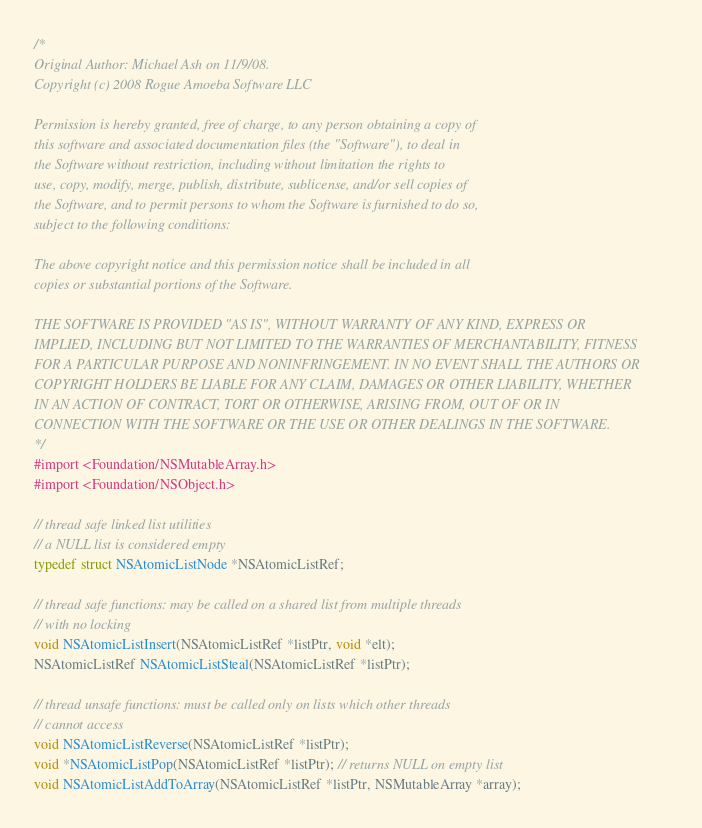Convert code to text. <code><loc_0><loc_0><loc_500><loc_500><_C_>/*
Original Author: Michael Ash on 11/9/08.
Copyright (c) 2008 Rogue Amoeba Software LLC

Permission is hereby granted, free of charge, to any person obtaining a copy of
this software and associated documentation files (the "Software"), to deal in
the Software without restriction, including without limitation the rights to
use, copy, modify, merge, publish, distribute, sublicense, and/or sell copies of
the Software, and to permit persons to whom the Software is furnished to do so,
subject to the following conditions:

The above copyright notice and this permission notice shall be included in all
copies or substantial portions of the Software.

THE SOFTWARE IS PROVIDED "AS IS", WITHOUT WARRANTY OF ANY KIND, EXPRESS OR
IMPLIED, INCLUDING BUT NOT LIMITED TO THE WARRANTIES OF MERCHANTABILITY, FITNESS
FOR A PARTICULAR PURPOSE AND NONINFRINGEMENT. IN NO EVENT SHALL THE AUTHORS OR
COPYRIGHT HOLDERS BE LIABLE FOR ANY CLAIM, DAMAGES OR OTHER LIABILITY, WHETHER
IN AN ACTION OF CONTRACT, TORT OR OTHERWISE, ARISING FROM, OUT OF OR IN
CONNECTION WITH THE SOFTWARE OR THE USE OR OTHER DEALINGS IN THE SOFTWARE.
*/
#import <Foundation/NSMutableArray.h>
#import <Foundation/NSObject.h>

// thread safe linked list utilities
// a NULL list is considered empty
typedef struct NSAtomicListNode *NSAtomicListRef;

// thread safe functions: may be called on a shared list from multiple threads
// with no locking
void NSAtomicListInsert(NSAtomicListRef *listPtr, void *elt);
NSAtomicListRef NSAtomicListSteal(NSAtomicListRef *listPtr);

// thread unsafe functions: must be called only on lists which other threads
// cannot access
void NSAtomicListReverse(NSAtomicListRef *listPtr);
void *NSAtomicListPop(NSAtomicListRef *listPtr); // returns NULL on empty list
void NSAtomicListAddToArray(NSAtomicListRef *listPtr, NSMutableArray *array);
</code> 